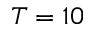<formula> <loc_0><loc_0><loc_500><loc_500>T = 1 0</formula> 